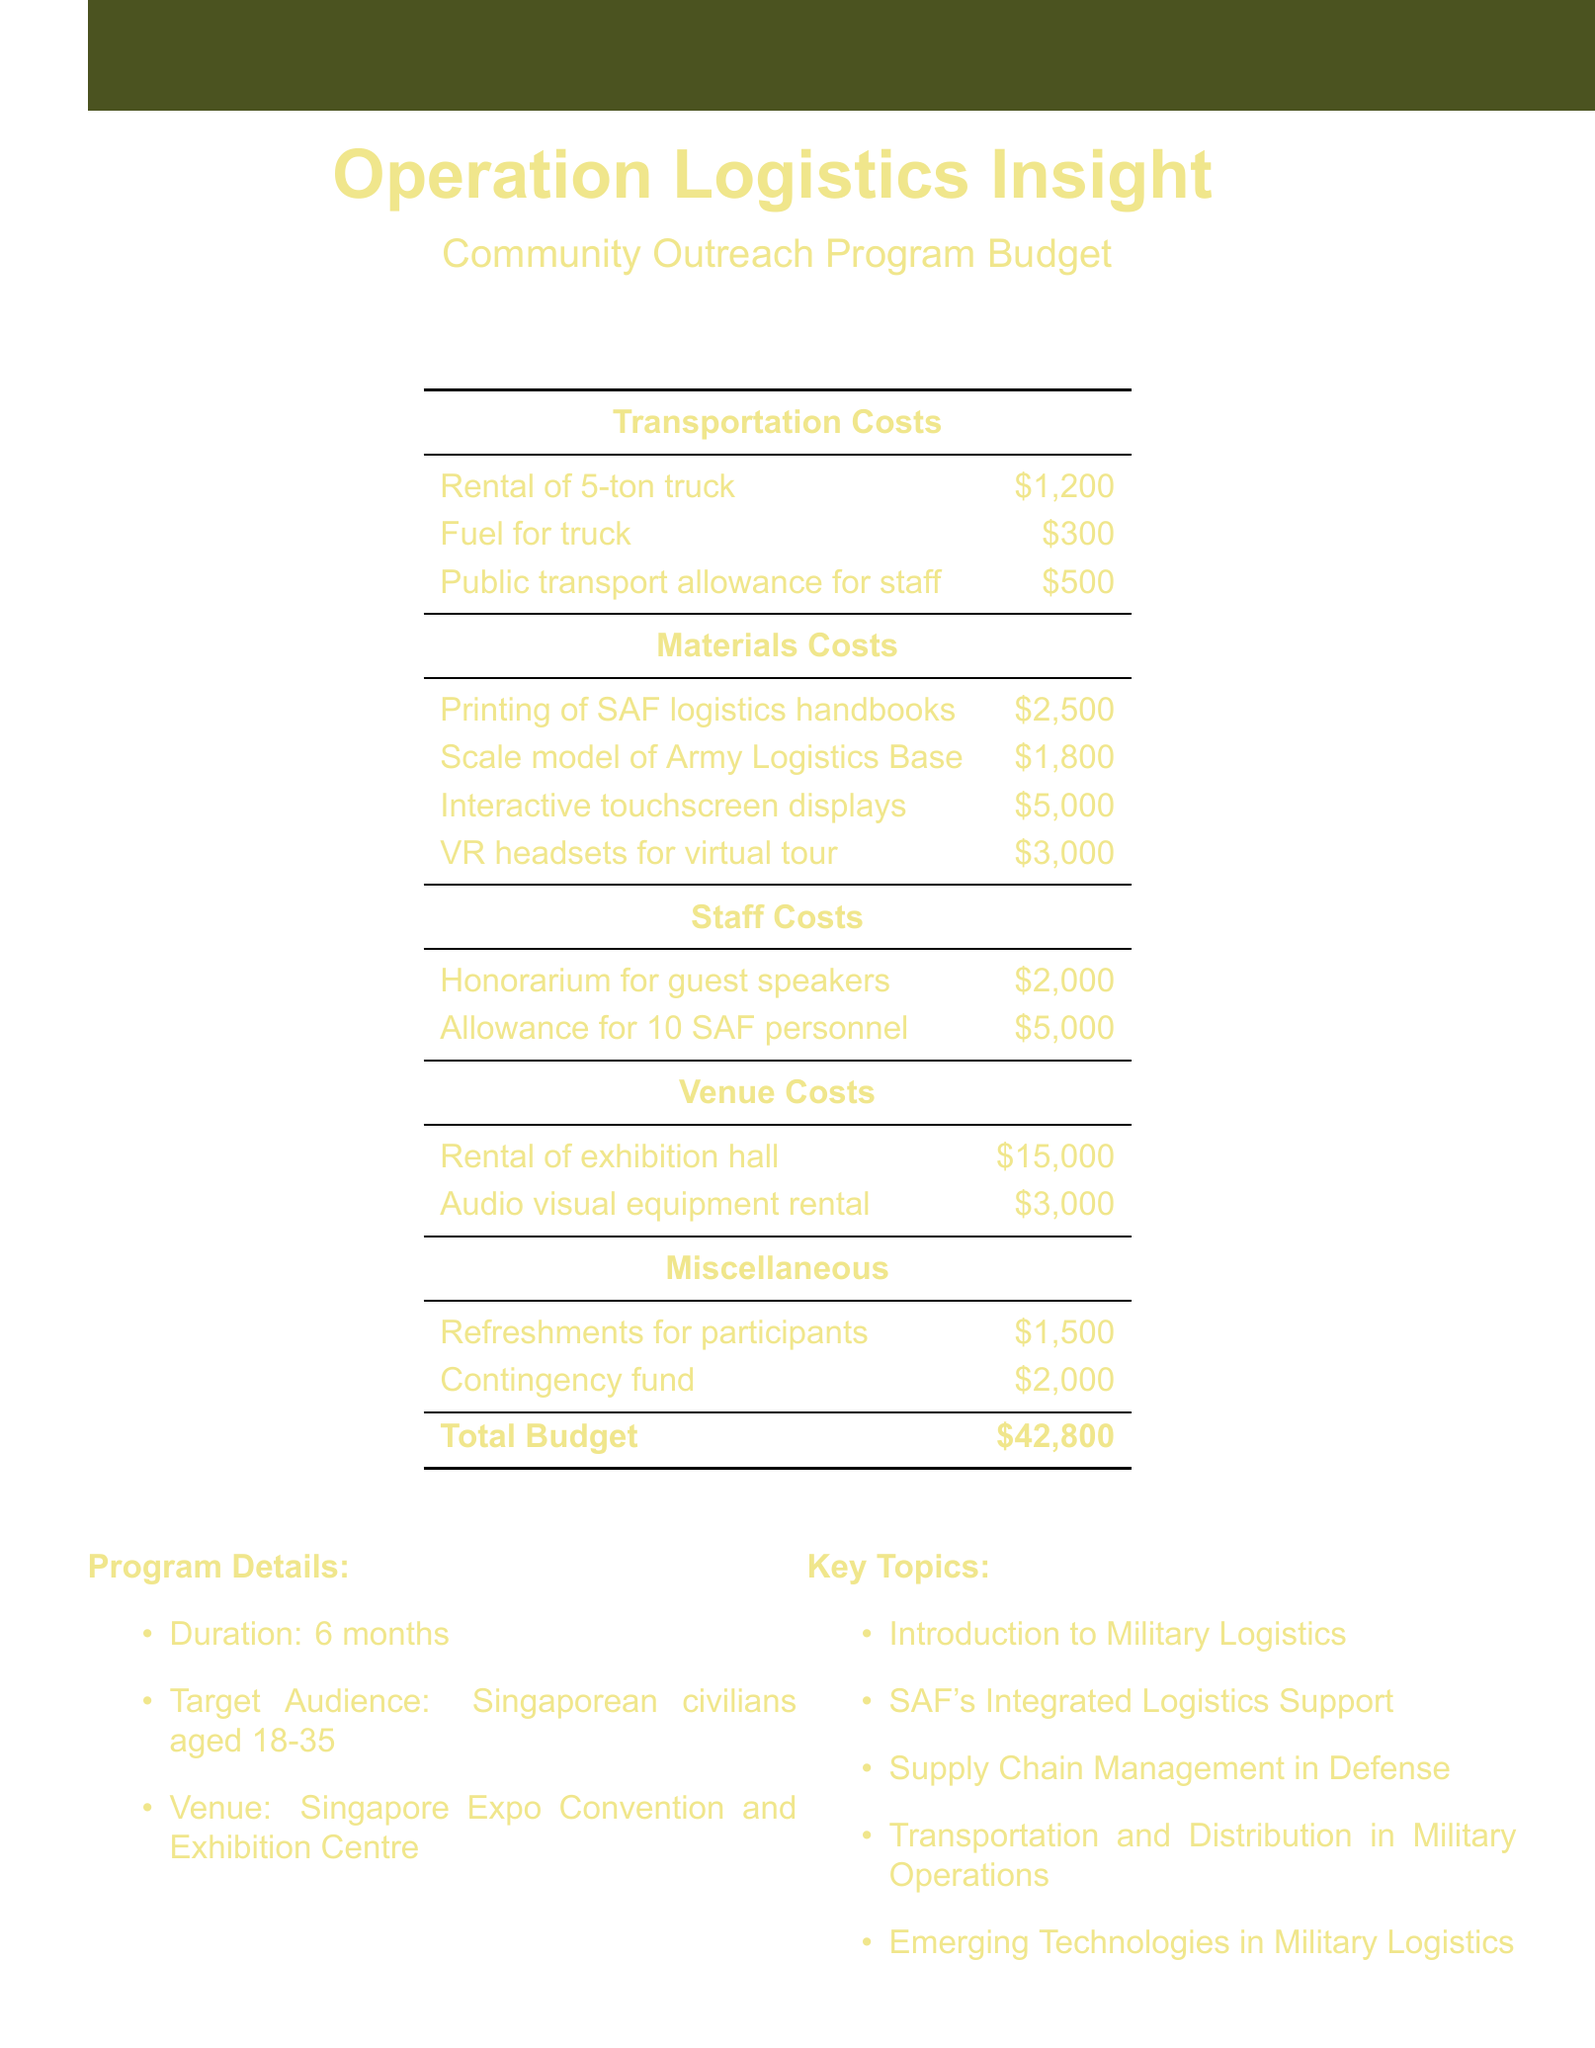What is the total budget for the program? The total budget is the sum of all costs listed, which is $42,800.
Answer: $42,800 What is the rental cost of the exhibition hall? The rental cost of the exhibition hall is specified in the venue costs section as $15,000.
Answer: $15,000 How much is allocated for printing logistics handbooks? The cost for printing SAF logistics handbooks is detailed under materials costs as $2,500.
Answer: $2,500 What is the total allowance for SAF personnel? The total allowance for 10 SAF personnel is listed under staff costs, which amounts to $5,000.
Answer: $5,000 How many months does the program run? The document states that the program duration is 6 months.
Answer: 6 months What is one of the key topics related to military logistics? The document outlines several key topics, such as "Transportation and Distribution in Military Operations."
Answer: Transportation and Distribution in Military Operations What is the budget allocation for VR headsets? The budget for VR headsets is mentioned under materials costs as $3,000.
Answer: $3,000 What type of venue is the program held at? The document specifies the venue as the "Singapore Expo Convention and Exhibition Centre."
Answer: Singapore Expo Convention and Exhibition Centre Who is responsible for inviting guest speakers? The honorarium for guest speakers is listed under staff costs in the budget.
Answer: Guest speakers 